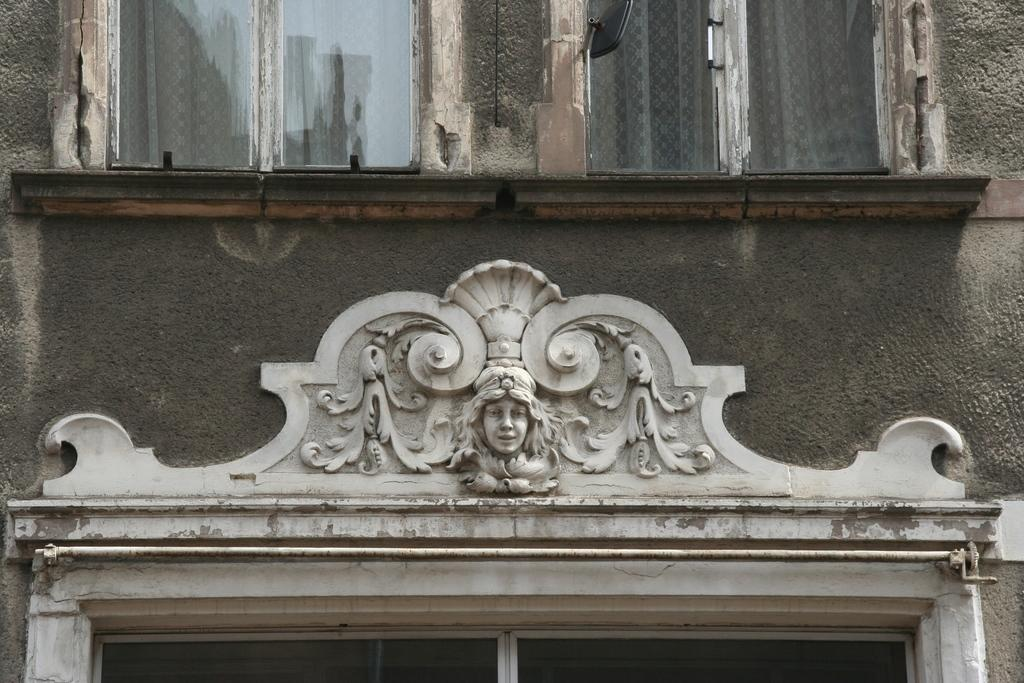What is present on the wall in the image? There are sculptures on the wall in the image. What other architectural features can be seen in the image? There are windows in the image. Can you describe the wall in the image? The wall has sculptures on it and is likely part of a building or structure. How does the wall affect the power consumption in the image? The image does not provide any information about power consumption, so it cannot be determined how the wall affects it. 